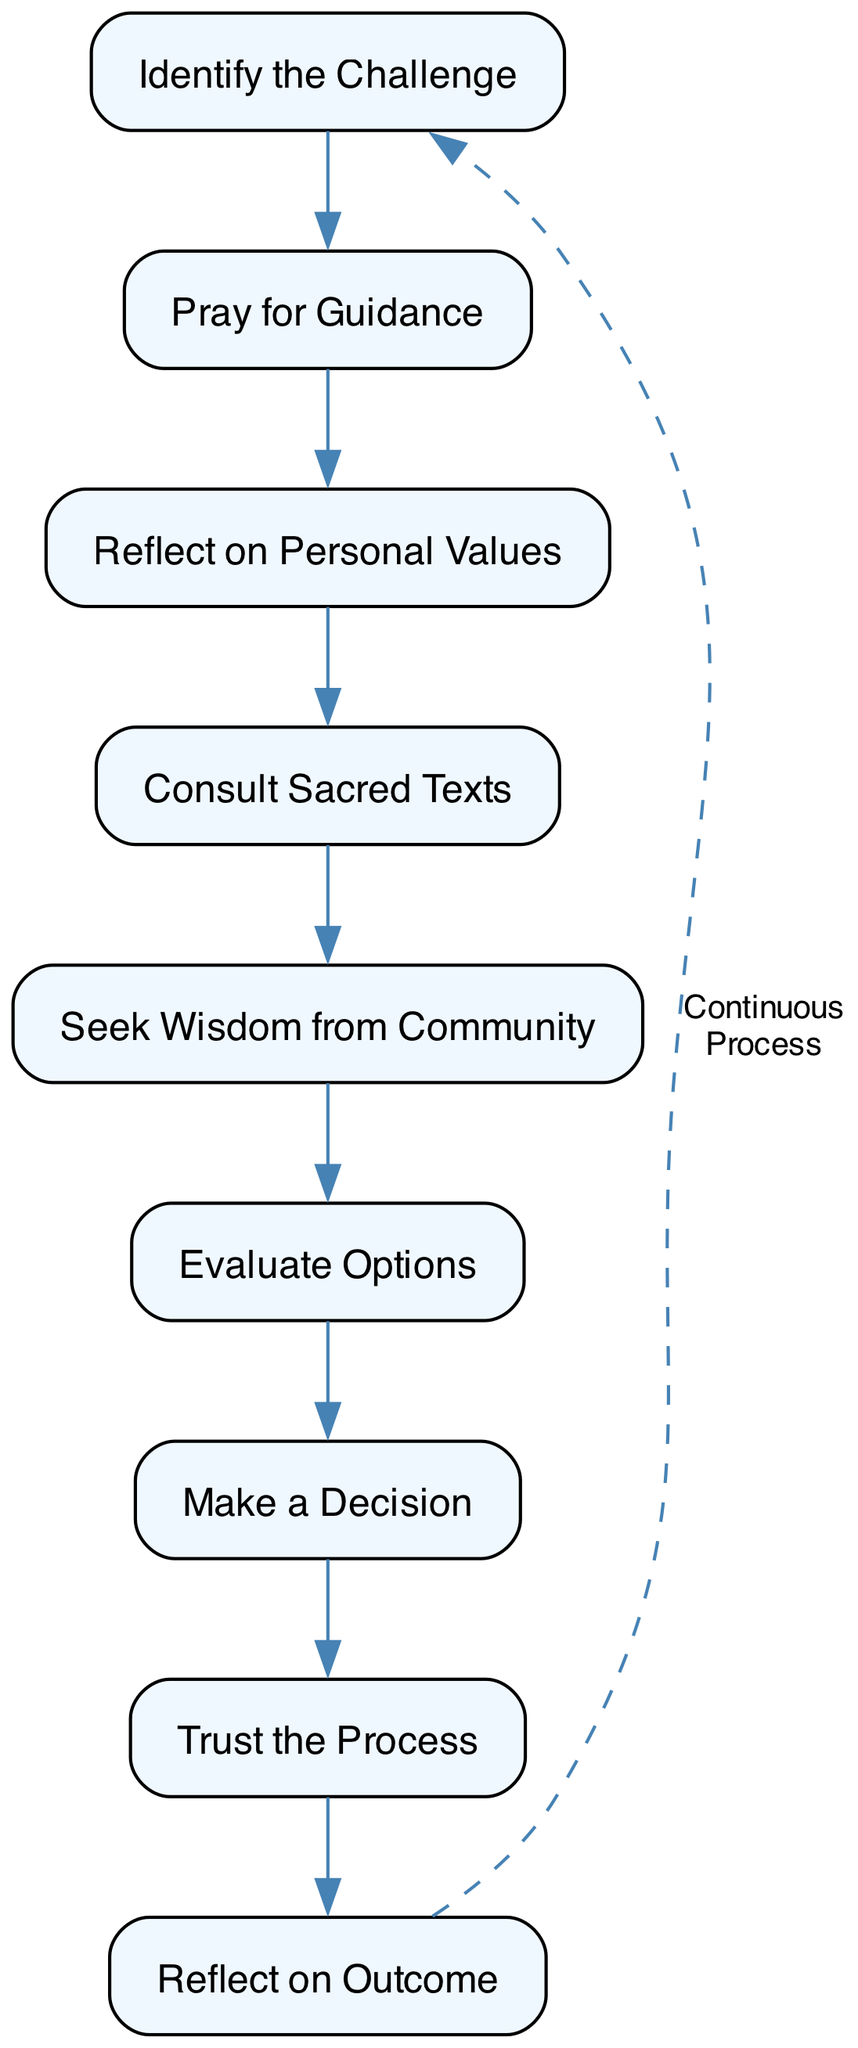What is the first step in the process? The first step in the flow chart is "Identify the Challenge," which signifies the beginning of the decision-making process. You can see this as the top node in the diagram.
Answer: Identify the Challenge How many nodes are in the diagram? The diagram contains nine nodes, each representing a unique step in the faith-based decision-making process. By counting each distinct element, we arrive at this total.
Answer: Nine What is the last step before reflecting on the outcome? The last step before "Reflect on Outcome" is "Make a Decision." This can be identified as the node directly preceding the reflection step in the sequence of the chart.
Answer: Make a Decision Which two steps are directly connected with an edge? The steps "Consult Sacred Texts" and "Seek Wisdom from Community" are directly connected with an edge, indicating a sequential relationship in the decision-making process. The flow is established by the edges that connect these nodes directly.
Answer: Consult Sacred Texts, Seek Wisdom from Community What does the dashed edge represent? The dashed edge indicates a "Continuous Process," illustrating that after reflecting on the outcome, one can cycle back to identify new challenges. This is a unique feature of flow charts where cyclical processes are depicted.
Answer: Continuous Process How many edges are leading into the "Make a Decision" node? There are three edges leading into the "Make a Decision" node, coming from the previous steps of evaluating options, reflecting on values, and consulting sacred texts. By following the diagram’s flow, we identify these connections.
Answer: Three What action will you take after reflecting on the outcome? After reflecting on the outcome, the next step is to “Trust the Process.” This highlights the faith aspect, where one has confidence in the chosen path post-reflection. The arrangement of steps leads to a clear understanding of the next action.
Answer: Trust the Process Which node suggests seeking advice from others? The node "Seek Wisdom from Community" suggests the action of seeking advice from trusted spiritual leaders or community members. This is explicitly stated in the node’s description, focusing on the importance of community guidance.
Answer: Seek Wisdom from Community Which two steps occur immediately before and after "Reflect on Outcome"? The step immediately before "Reflect on Outcome" is "Make a Decision," and the step immediately after is "Trust the Process." These adjacency relationships can be easily discerned by following the diagram's sequential flow.
Answer: Make a Decision, Trust the Process 